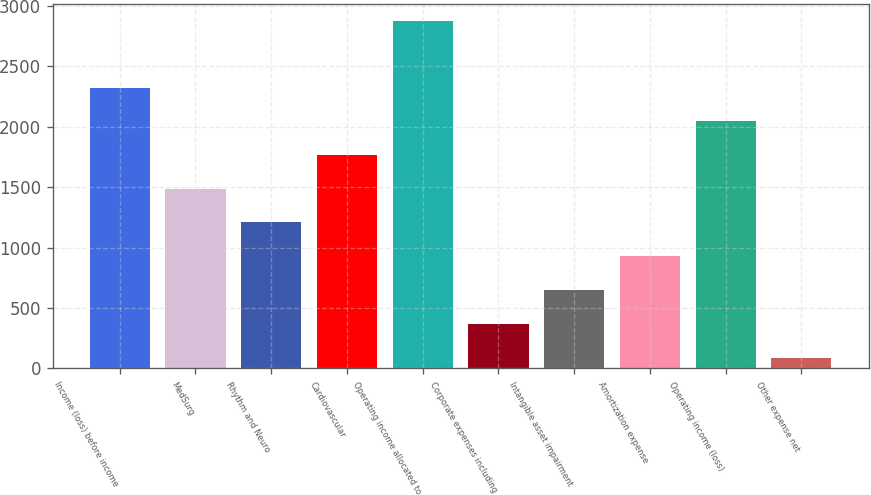Convert chart to OTSL. <chart><loc_0><loc_0><loc_500><loc_500><bar_chart><fcel>Income (loss) before income<fcel>MedSurg<fcel>Rhythm and Neuro<fcel>Cardiovascular<fcel>Operating income allocated to<fcel>Corporate expenses including<fcel>Intangible asset impairment<fcel>Amortization expense<fcel>Operating income (loss)<fcel>Other expense net<nl><fcel>2325<fcel>1488<fcel>1209<fcel>1767<fcel>2875<fcel>372<fcel>651<fcel>930<fcel>2046<fcel>85<nl></chart> 